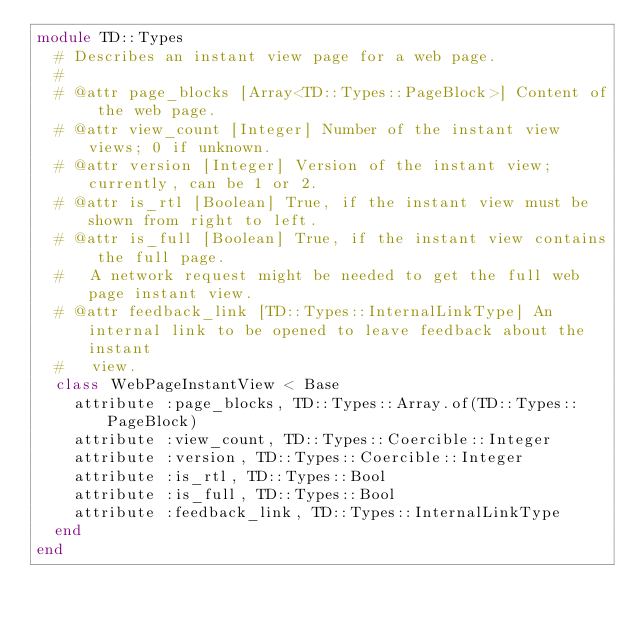Convert code to text. <code><loc_0><loc_0><loc_500><loc_500><_Ruby_>module TD::Types
  # Describes an instant view page for a web page.
  #
  # @attr page_blocks [Array<TD::Types::PageBlock>] Content of the web page.
  # @attr view_count [Integer] Number of the instant view views; 0 if unknown.
  # @attr version [Integer] Version of the instant view; currently, can be 1 or 2.
  # @attr is_rtl [Boolean] True, if the instant view must be shown from right to left.
  # @attr is_full [Boolean] True, if the instant view contains the full page.
  #   A network request might be needed to get the full web page instant view.
  # @attr feedback_link [TD::Types::InternalLinkType] An internal link to be opened to leave feedback about the instant
  #   view.
  class WebPageInstantView < Base
    attribute :page_blocks, TD::Types::Array.of(TD::Types::PageBlock)
    attribute :view_count, TD::Types::Coercible::Integer
    attribute :version, TD::Types::Coercible::Integer
    attribute :is_rtl, TD::Types::Bool
    attribute :is_full, TD::Types::Bool
    attribute :feedback_link, TD::Types::InternalLinkType
  end
end
</code> 